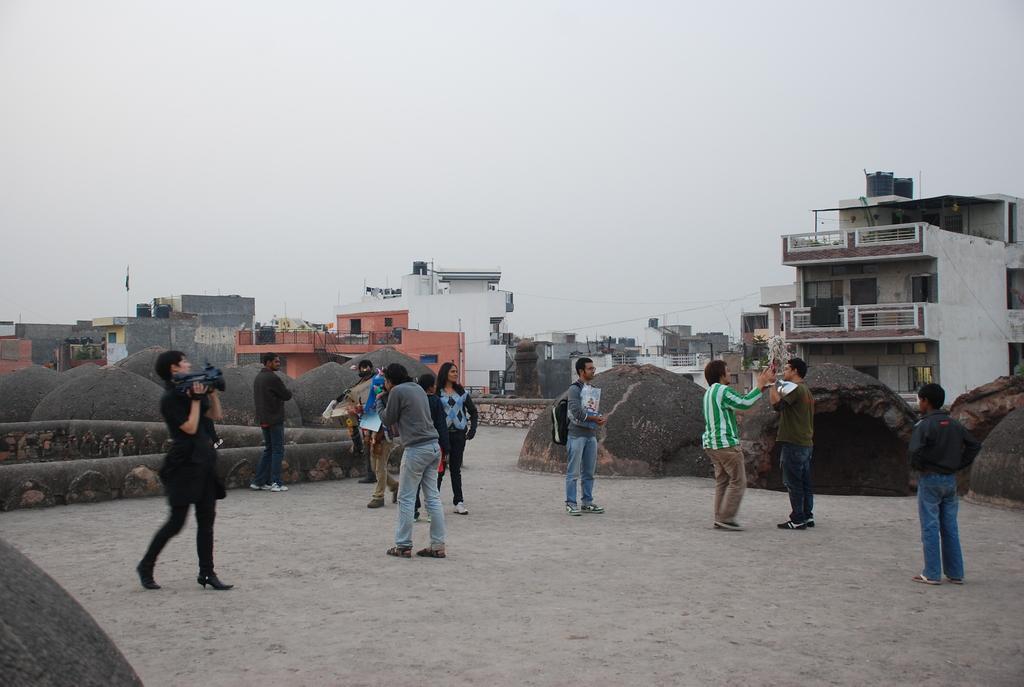Could you give a brief overview of what you see in this image? There are groups of people standing. Here is a woman holding a video recorder and walking. I can see the buildings with windows. These are the water tanks, which are at the top of the buildings. I think these are the kind of rocks. 